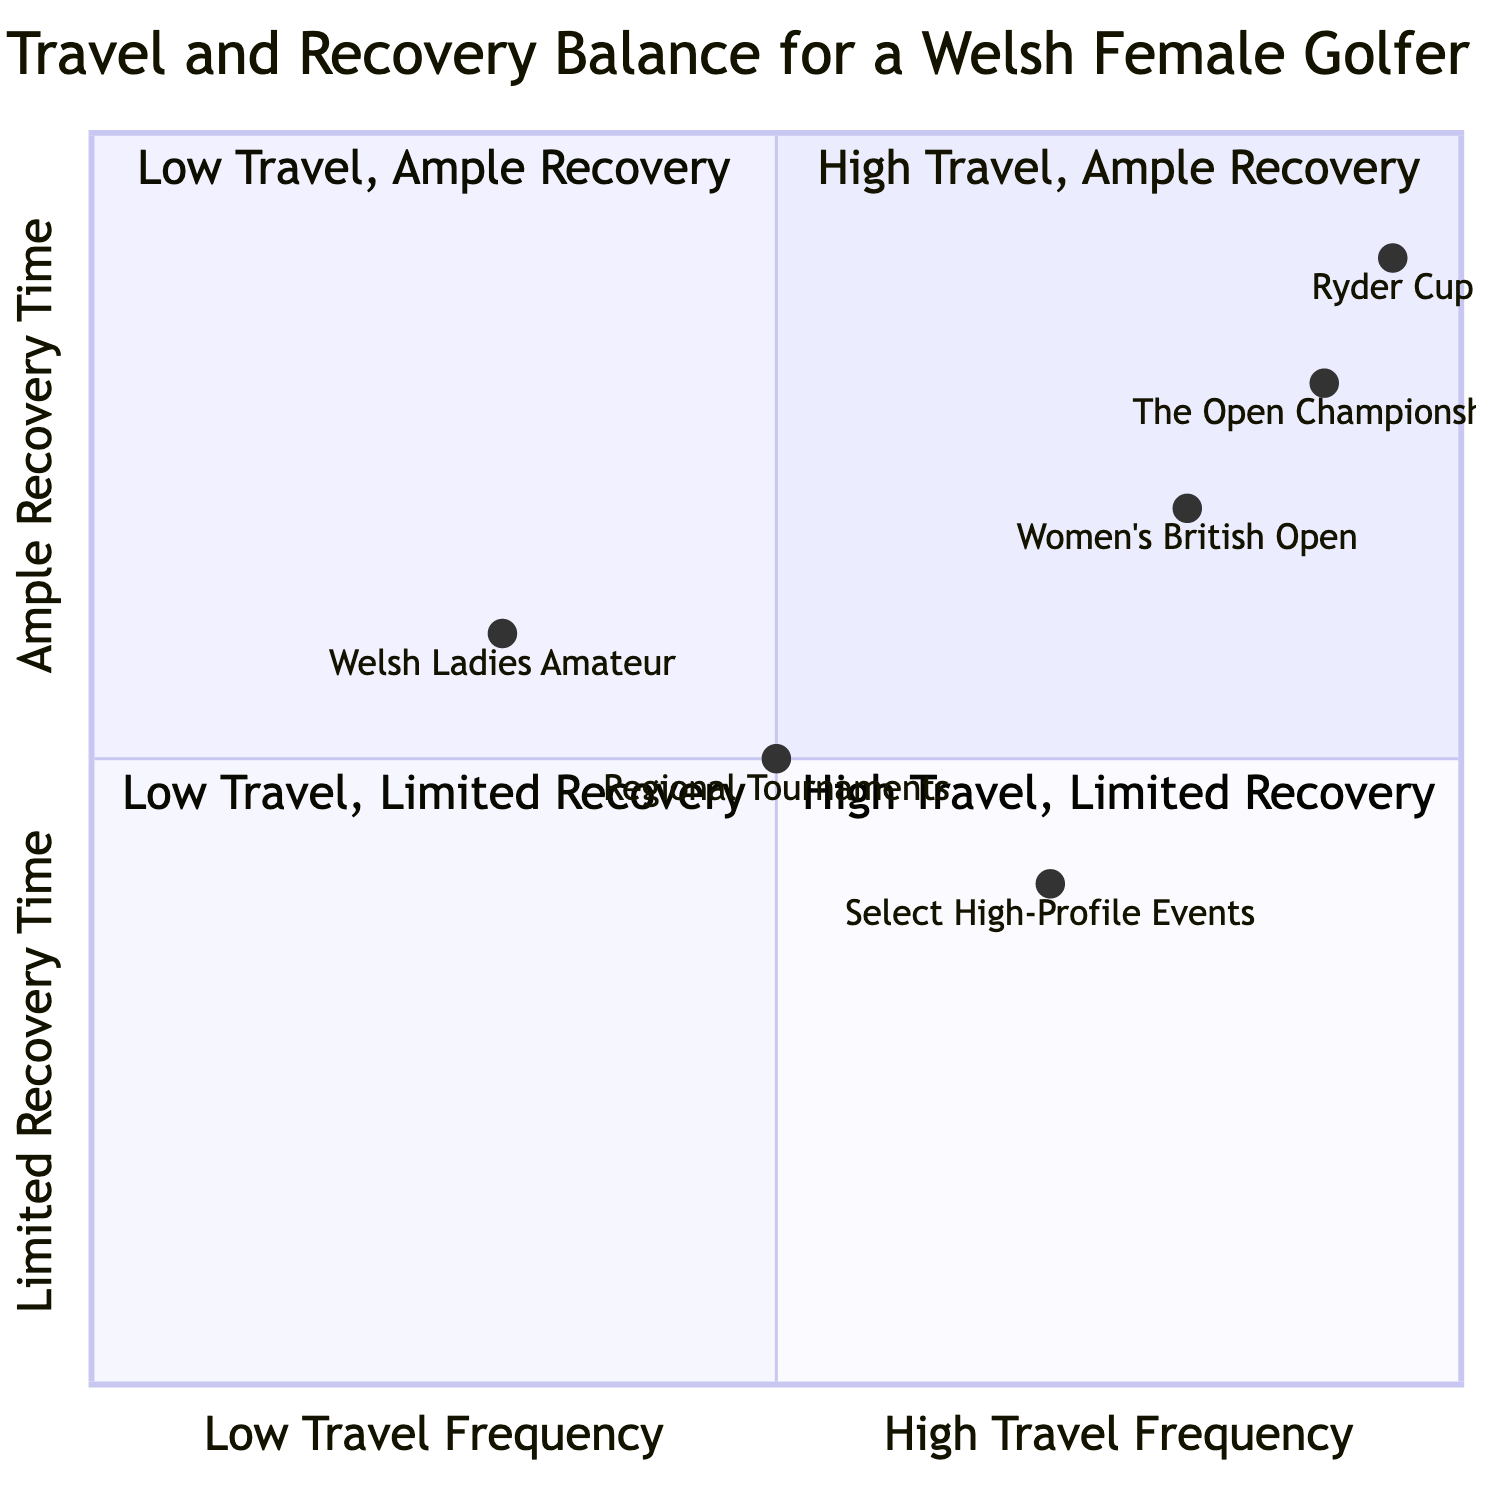What is the quadrant for The Open Championship? The data indicates that the coordinates for The Open Championship are [0.9, 0.8]. This places it in the High Travel, Ample Recovery quadrant, as it has a high travel frequency (close to 1) and ample recovery time (also close to 1).
Answer: High Travel, Ample Recovery Which tournament has the least recovery time? According to the data, Select High-Profile Events is represented by the coordinates [0.7, 0.4]. Since it has the lowest Y-value among all tournaments, it indicates limited recovery time.
Answer: Select High-Profile Events How many tournaments are in the High Travel, Limited Recovery quadrant? The only tournament in the High Travel, Limited Recovery quadrant is noted by the coordinates of The Open Championship and Select High-Profile Events. Only The Open Championship specifically exhibits high travel with limited recovery time based on its proximity to the quadrant limits.
Answer: 1 What is the travel frequency level of regional tournaments? The coordinates for Regional Tournaments are [0.5, 0.5], indicating a moderate travel frequency. The X-axis value of 0.5 reflects this moderate travel level.
Answer: Moderate Travel Frequency Which quadrant contains the most tournaments? The data suggests that multiple tournaments reside in the Moderate Travel, Moderate Recovery quadrant, including Regional Tournaments, making this quadrant the most populated based on the representation of tournaments in this area of the chart.
Answer: Moderate Travel, Moderate Recovery In which quadrant does the Women's British Open fall? The Women's British Open has coordinates [0.8, 0.7]. This indicates it is in the High Travel, Ample Recovery quadrant because both values are on the higher side of the scale, which translates to high travel and ample recovery.
Answer: High Travel, Ample Recovery How many total quadrants are represented in the diagram? The diagram is structured into four quadrants based on the combination of travel frequency and recovery time, hence the total number of quadrants illustrated is four.
Answer: 4 What is the recovery time for the Ryder Cup? The Ryder Cup has coordinates of [0.95, 0.9], indicating a recovery time classified as ample due to its high Y-value. This strong accomplishment in performance is linked to high recovery potential.
Answer: Ample Recovery Time Which type of travel frequency is predominately associated with high performance? The analysis indicates that players managing to balance high travel frequency with ample recovery likely achieve high performance levels, thus linking better performance outcomes to high frequency travel given the right recovery.
Answer: High Travel Frequency 